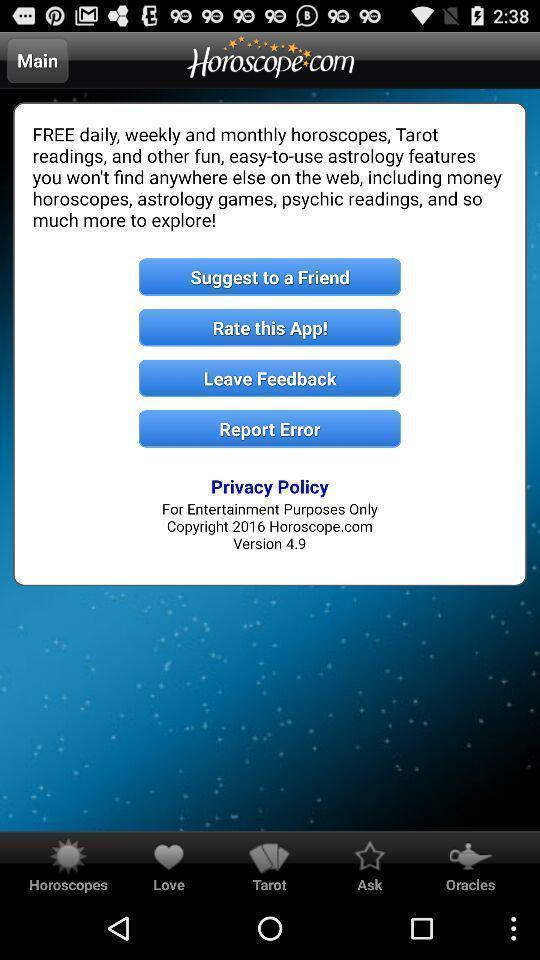Explain the elements present in this screenshot. Pop up message. 